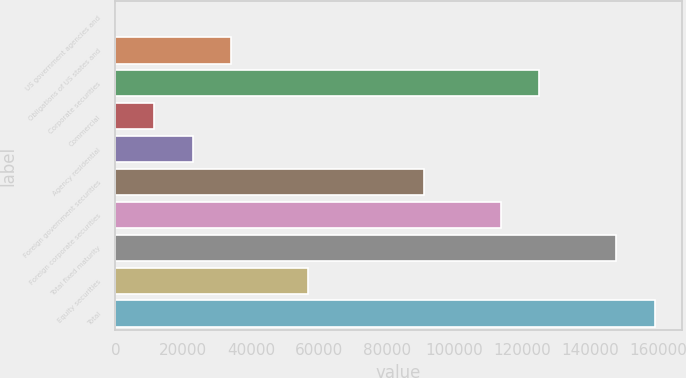Convert chart. <chart><loc_0><loc_0><loc_500><loc_500><bar_chart><fcel>US government agencies and<fcel>Obligations of US states and<fcel>Corporate securities<fcel>Commercial<fcel>Agency residential<fcel>Foreign government securities<fcel>Foreign corporate securities<fcel>Total fixed maturity<fcel>Equity securities<fcel>Total<nl><fcel>20<fcel>34089.2<fcel>124940<fcel>11376.4<fcel>22732.8<fcel>90871.2<fcel>113584<fcel>147653<fcel>56802<fcel>159010<nl></chart> 